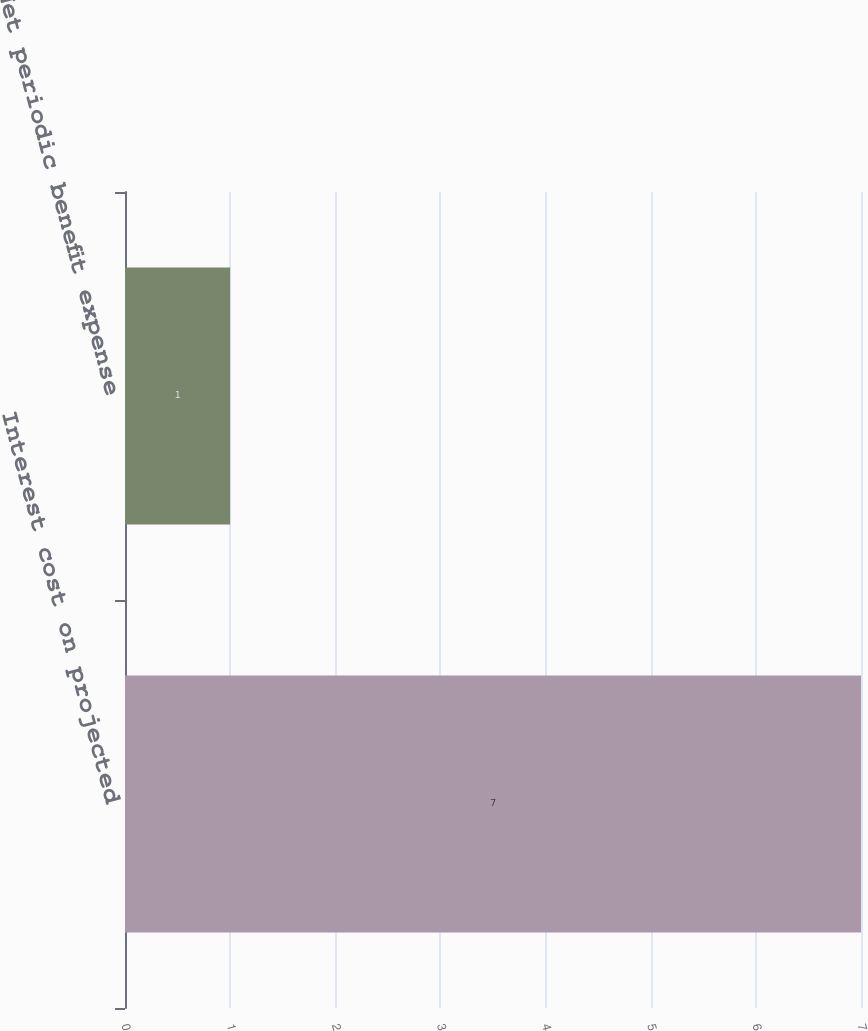Convert chart to OTSL. <chart><loc_0><loc_0><loc_500><loc_500><bar_chart><fcel>Interest cost on projected<fcel>Net periodic benefit expense<nl><fcel>7<fcel>1<nl></chart> 